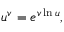Convert formula to latex. <formula><loc_0><loc_0><loc_500><loc_500>u ^ { v } = e ^ { v \ln u } ,</formula> 